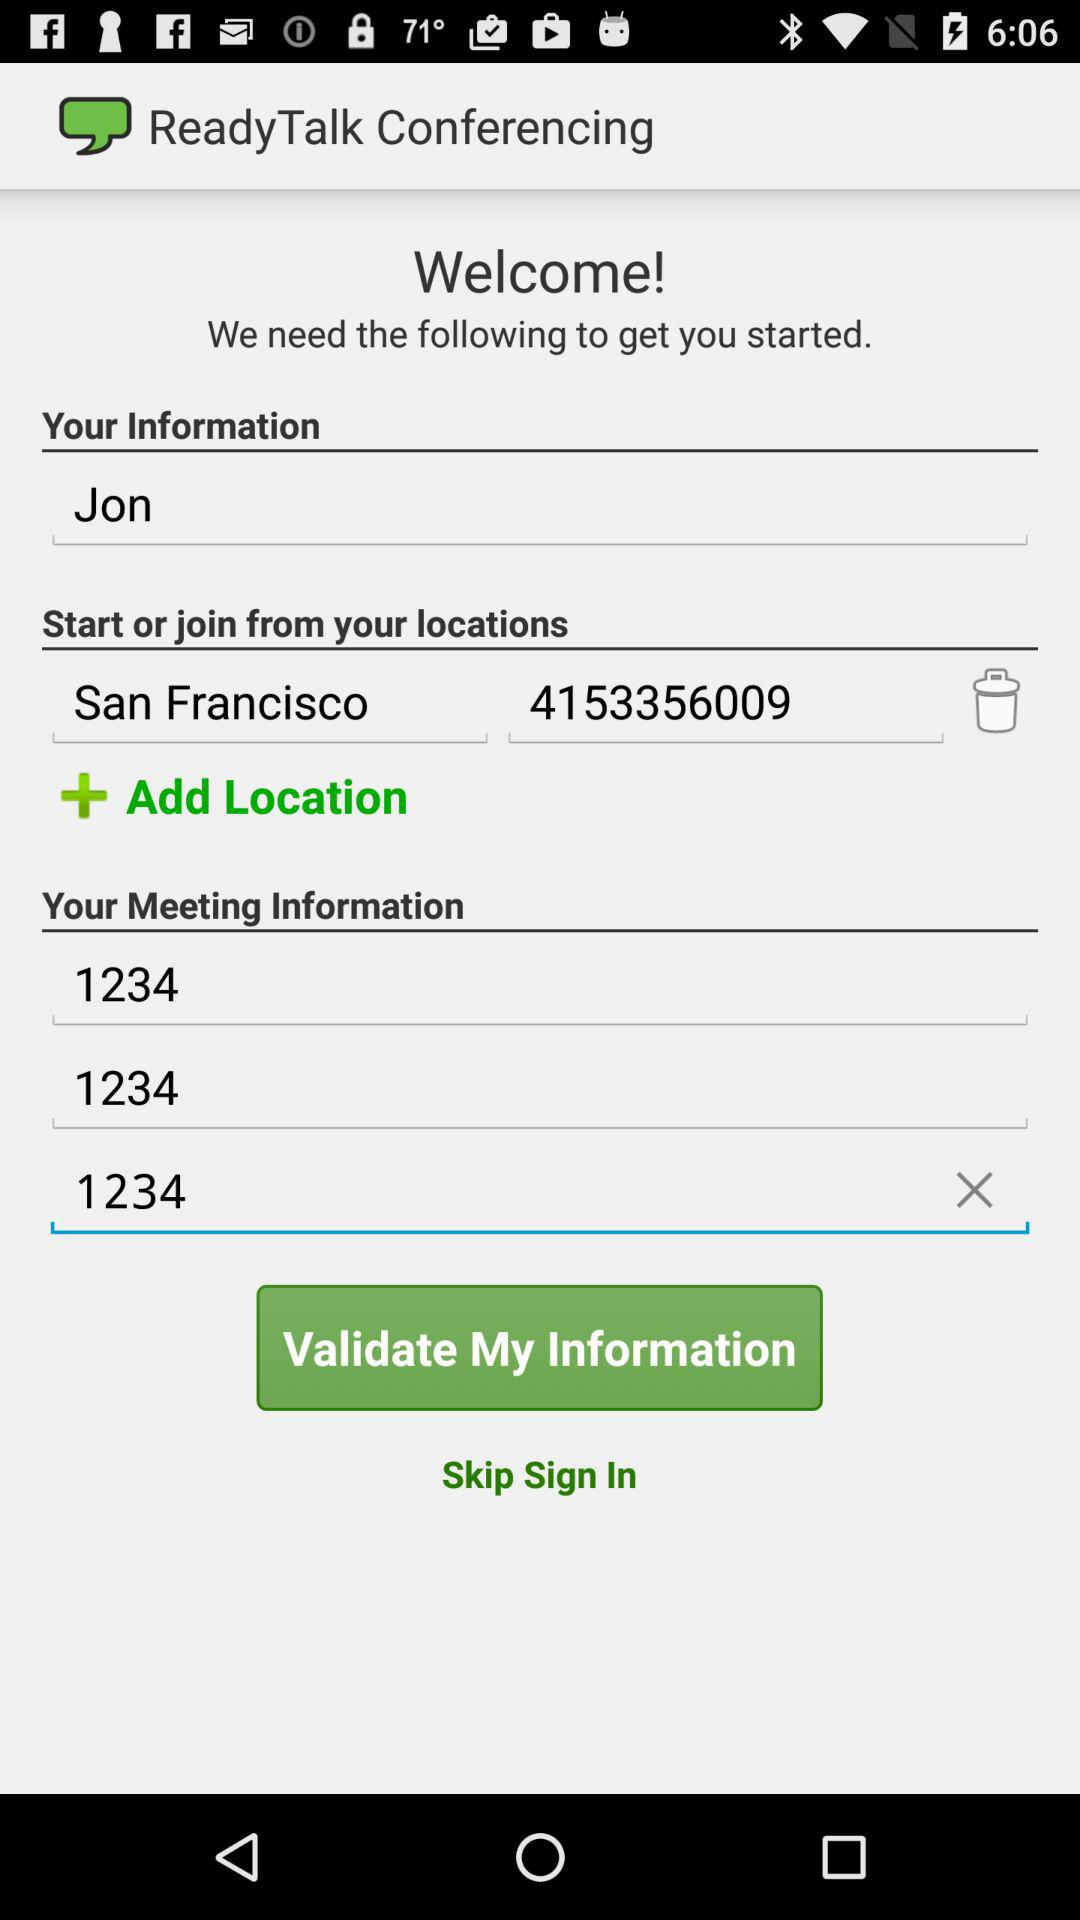What are the locations? The location is San Francisco. 